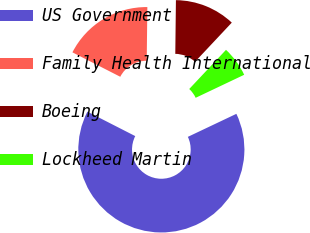<chart> <loc_0><loc_0><loc_500><loc_500><pie_chart><fcel>US Government<fcel>Family Health International<fcel>Boeing<fcel>Lockheed Martin<nl><fcel>64.56%<fcel>17.67%<fcel>11.81%<fcel>5.95%<nl></chart> 